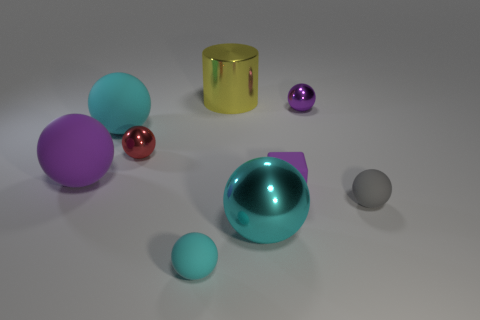Is there a large yellow object made of the same material as the small cube?
Ensure brevity in your answer.  No. What material is the tiny red ball?
Give a very brief answer. Metal. The purple matte thing left of the small metal ball in front of the shiny sphere behind the red shiny sphere is what shape?
Give a very brief answer. Sphere. Is the number of purple balls on the left side of the large purple matte thing greater than the number of purple blocks?
Provide a succinct answer. No. Does the tiny cyan matte thing have the same shape as the large metallic thing behind the gray matte ball?
Give a very brief answer. No. There is a shiny thing that is the same color as the tiny rubber block; what shape is it?
Give a very brief answer. Sphere. There is a rubber object to the left of the big cyan object that is behind the tiny rubber block; what number of tiny objects are right of it?
Provide a short and direct response. 5. What color is the shiny ball that is the same size as the red thing?
Provide a short and direct response. Purple. How big is the cyan object in front of the shiny thing that is in front of the gray thing?
Provide a succinct answer. Small. There is a matte object that is the same color as the tiny cube; what is its size?
Ensure brevity in your answer.  Large. 